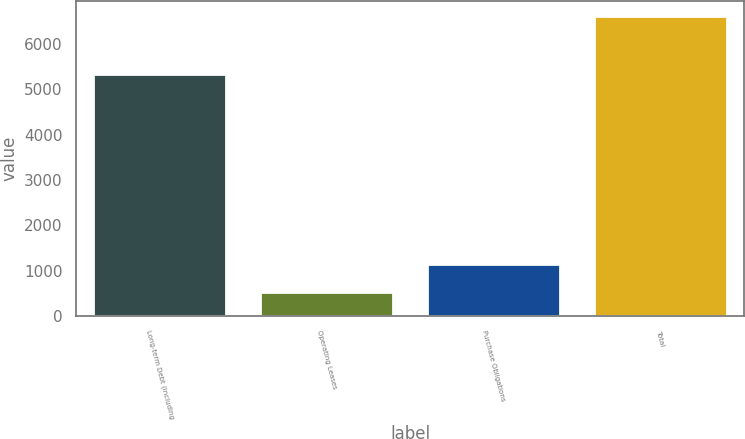Convert chart to OTSL. <chart><loc_0><loc_0><loc_500><loc_500><bar_chart><fcel>Long-term Debt (including<fcel>Operating Leases<fcel>Purchase Obligations<fcel>Total<nl><fcel>5342<fcel>536<fcel>1144.8<fcel>6624<nl></chart> 